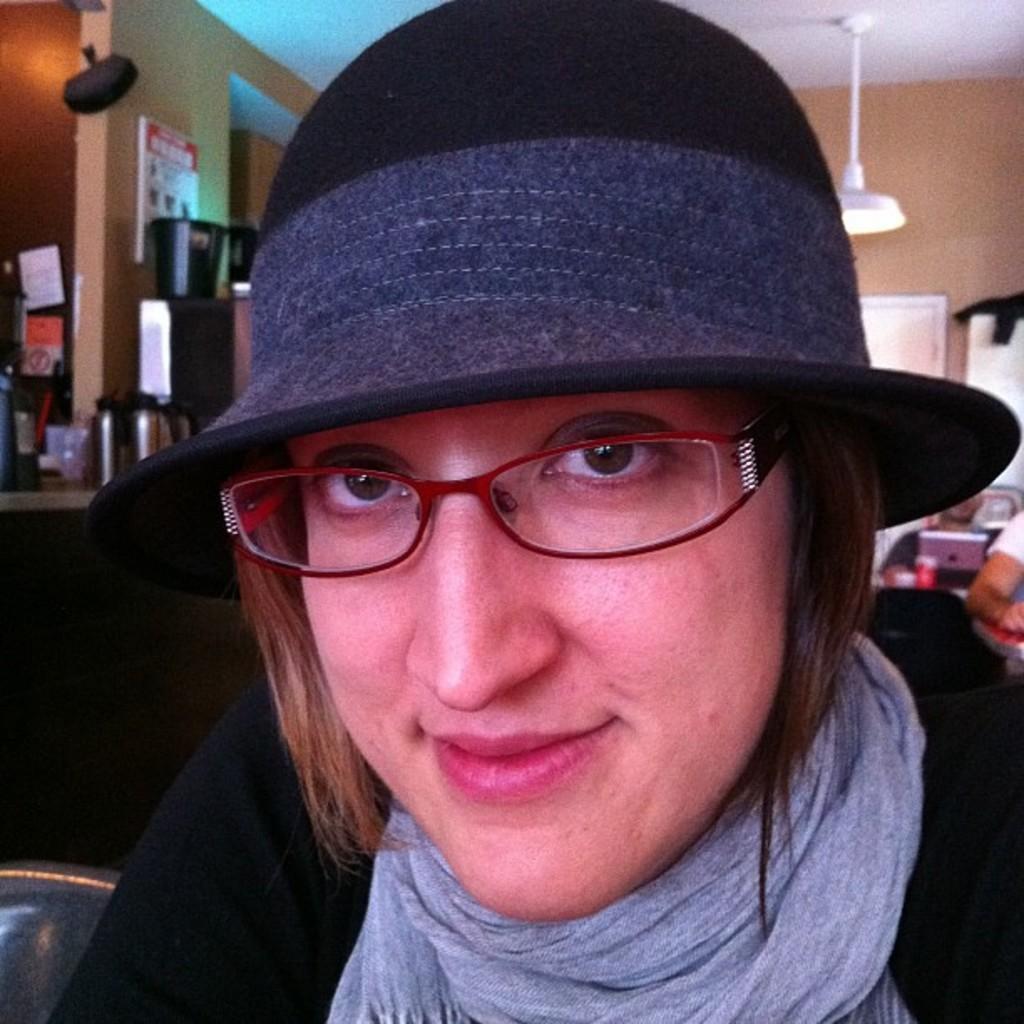How would you summarize this image in a sentence or two? This woman wore spectacles, cap and scarf. Background we can see people, laptop, cup, light, boards, bottles and things. This light is attached to the ceiling. Boards are on walls. 